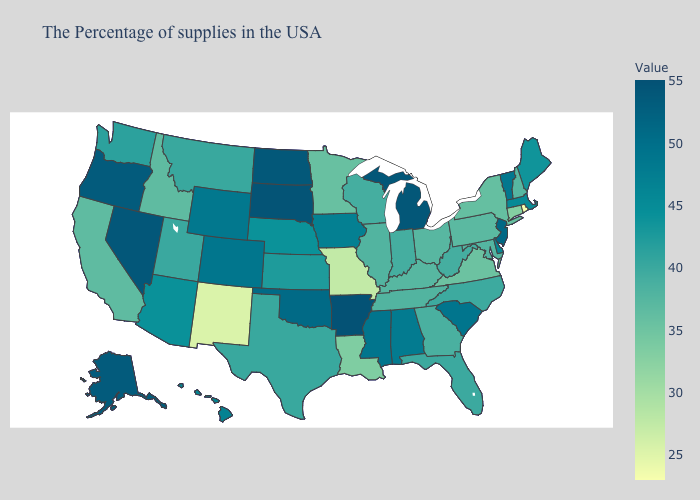Which states have the highest value in the USA?
Concise answer only. Arkansas. Does Rhode Island have the lowest value in the Northeast?
Keep it brief. Yes. Which states hav the highest value in the Northeast?
Keep it brief. New Jersey. Which states hav the highest value in the MidWest?
Be succinct. South Dakota. Which states have the highest value in the USA?
Answer briefly. Arkansas. Does Minnesota have the highest value in the USA?
Concise answer only. No. Among the states that border Indiana , does Kentucky have the highest value?
Keep it brief. No. Which states have the lowest value in the USA?
Concise answer only. Rhode Island. 